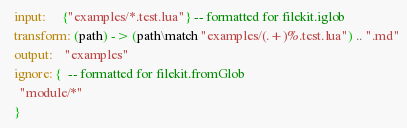<code> <loc_0><loc_0><loc_500><loc_500><_MoonScript_>  input:     {"examples/*.test.lua"} -- formatted for filekit.iglob
  transform: (path) -> (path\match "examples/(.+)%.test.lua") .. ".md"
  output:    "examples"
  ignore: {  -- formatted for filekit.fromGlob
    "module/*"
  }</code> 